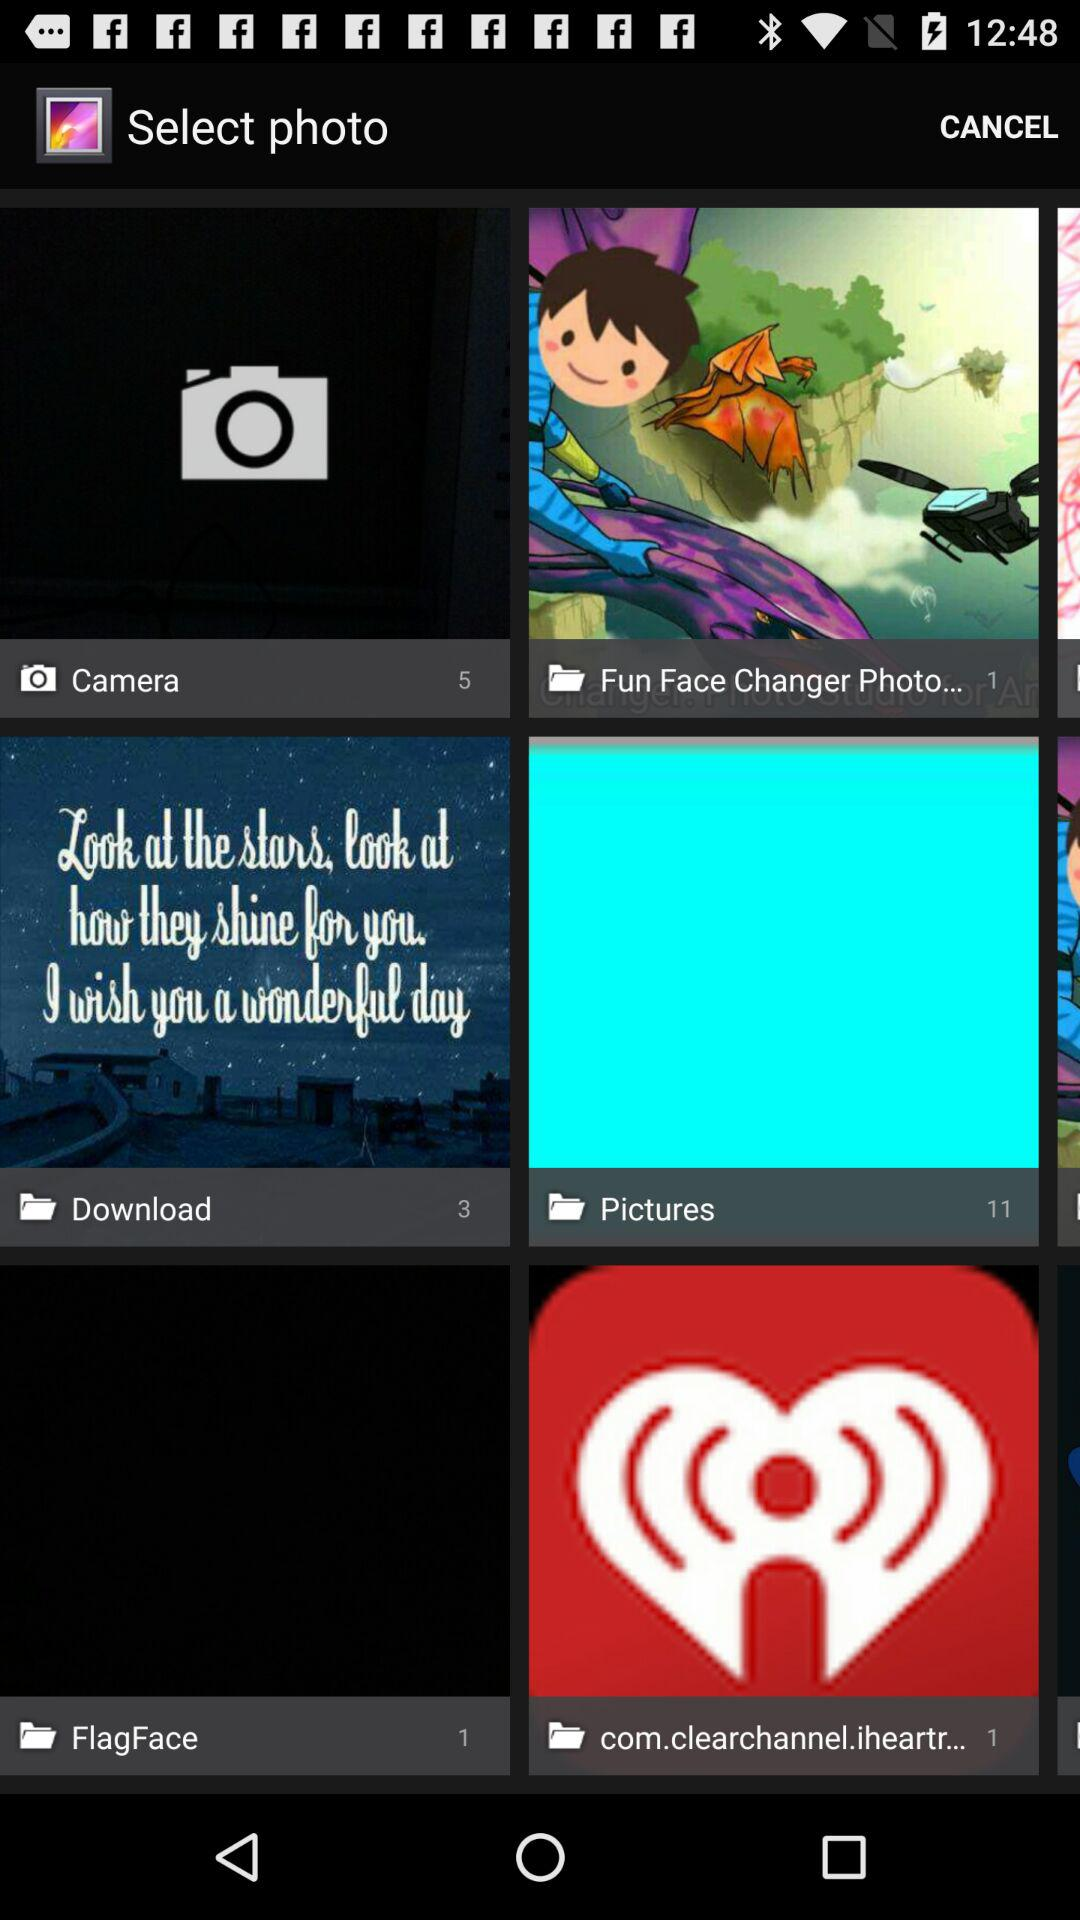How many files are in the "Download" folder? There are 3 files in the "Download" folder. 